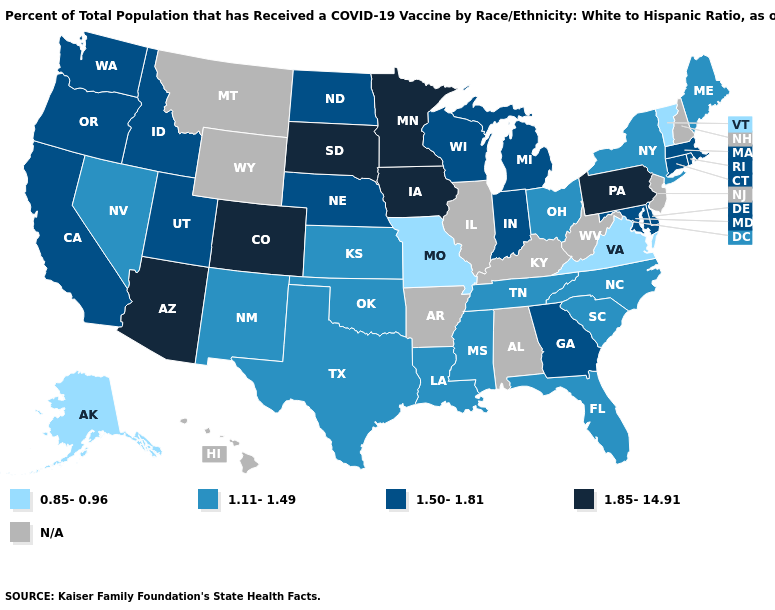What is the lowest value in the USA?
Short answer required. 0.85-0.96. Among the states that border Missouri , does Nebraska have the highest value?
Write a very short answer. No. What is the lowest value in the South?
Quick response, please. 0.85-0.96. What is the highest value in states that border Wyoming?
Quick response, please. 1.85-14.91. Name the states that have a value in the range 1.11-1.49?
Write a very short answer. Florida, Kansas, Louisiana, Maine, Mississippi, Nevada, New Mexico, New York, North Carolina, Ohio, Oklahoma, South Carolina, Tennessee, Texas. What is the value of New Hampshire?
Quick response, please. N/A. What is the value of Rhode Island?
Concise answer only. 1.50-1.81. Does Colorado have the highest value in the USA?
Concise answer only. Yes. Which states have the highest value in the USA?
Answer briefly. Arizona, Colorado, Iowa, Minnesota, Pennsylvania, South Dakota. Name the states that have a value in the range 0.85-0.96?
Answer briefly. Alaska, Missouri, Vermont, Virginia. Among the states that border Kentucky , which have the highest value?
Keep it brief. Indiana. Name the states that have a value in the range 0.85-0.96?
Short answer required. Alaska, Missouri, Vermont, Virginia. Which states hav the highest value in the West?
Give a very brief answer. Arizona, Colorado. Does Connecticut have the highest value in the Northeast?
Write a very short answer. No. 